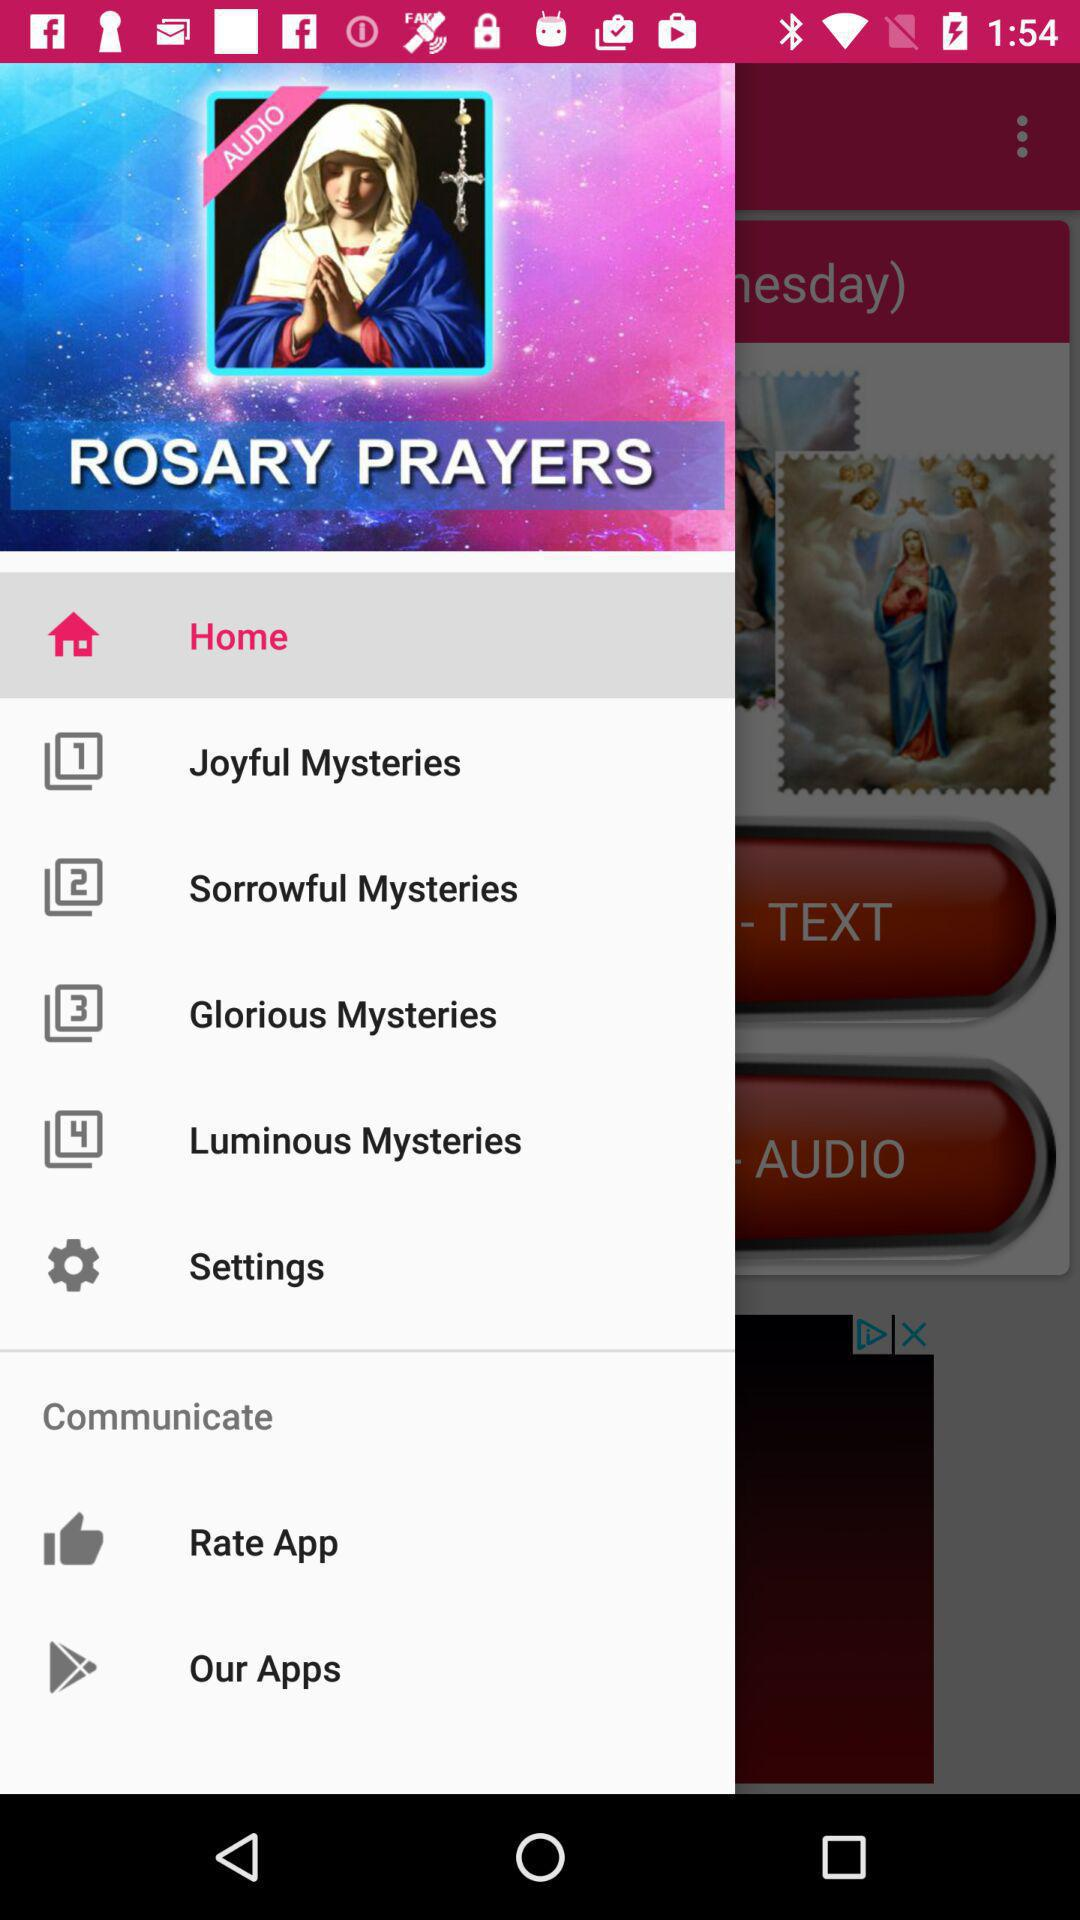What is the name of the application? The name of the application is "ROSARY PRAYERS". 